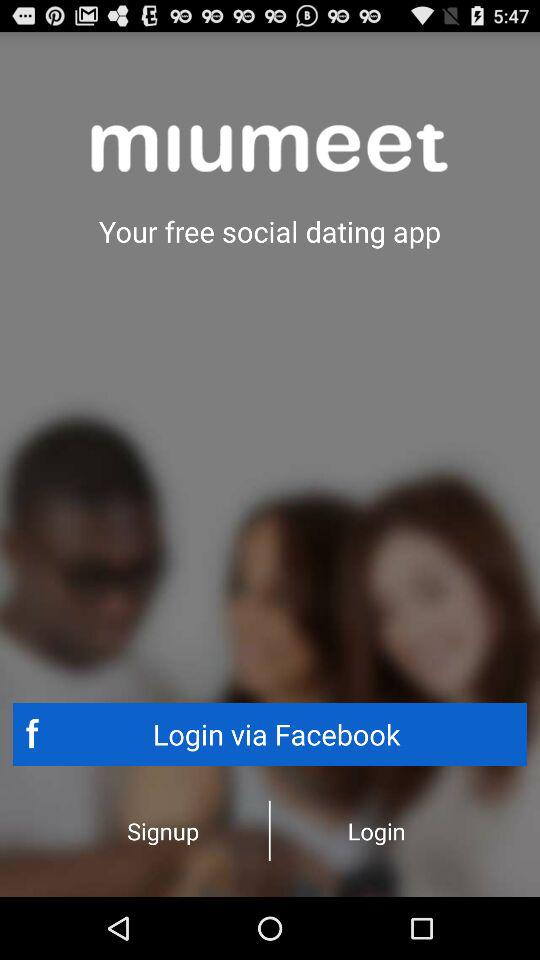By what apps can we log in? You can log in with "Facebook". 